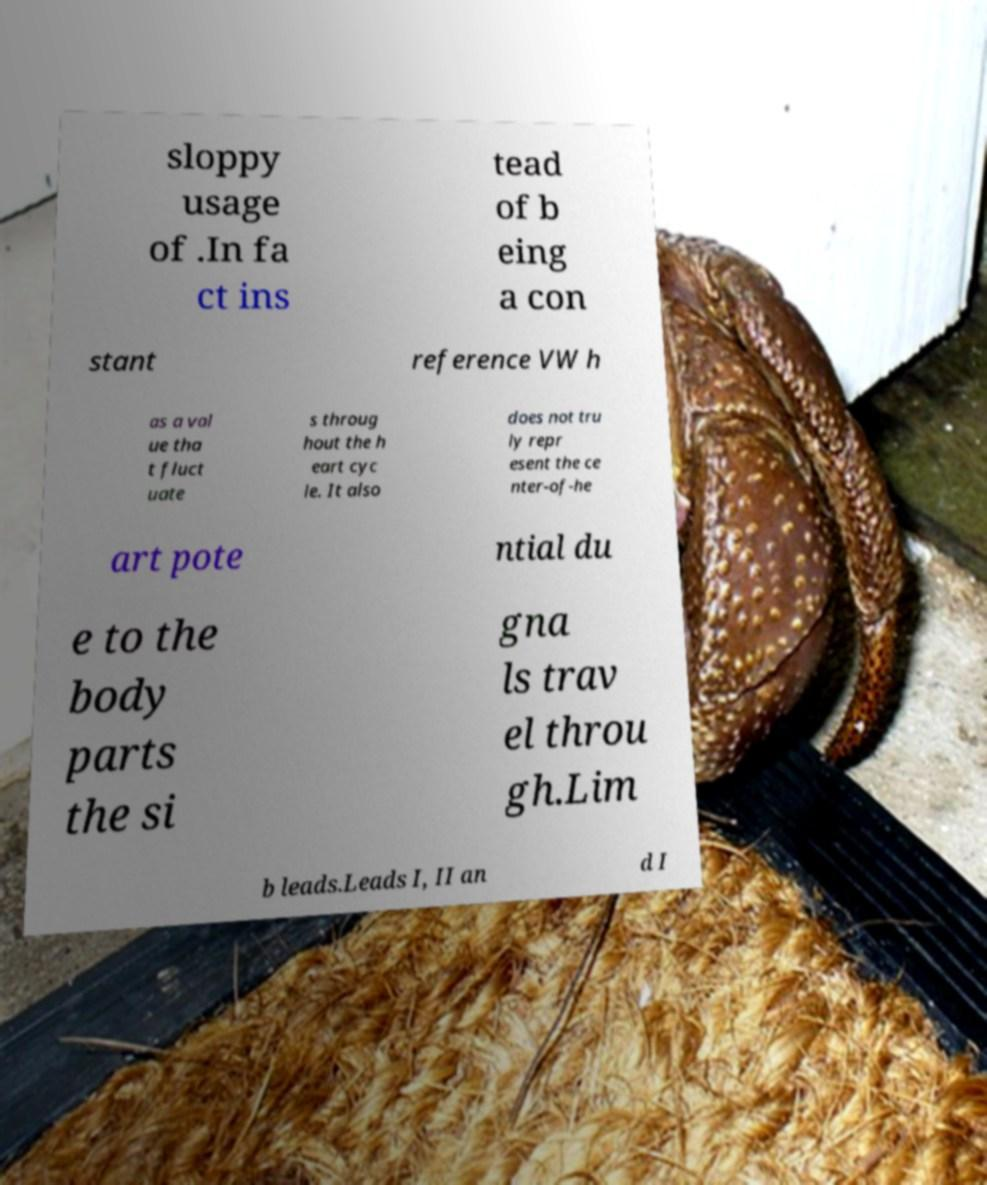Can you read and provide the text displayed in the image?This photo seems to have some interesting text. Can you extract and type it out for me? sloppy usage of .In fa ct ins tead of b eing a con stant reference VW h as a val ue tha t fluct uate s throug hout the h eart cyc le. It also does not tru ly repr esent the ce nter-of-he art pote ntial du e to the body parts the si gna ls trav el throu gh.Lim b leads.Leads I, II an d I 